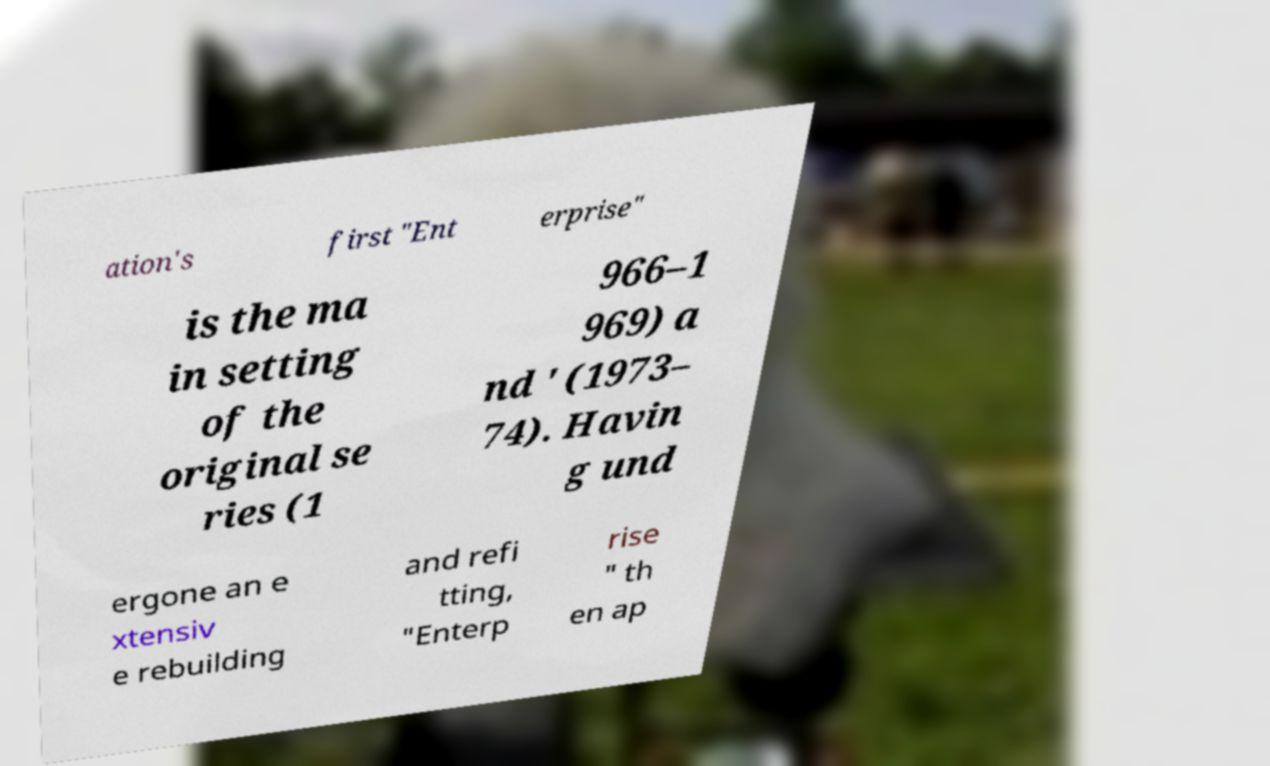Could you assist in decoding the text presented in this image and type it out clearly? ation's first "Ent erprise" is the ma in setting of the original se ries (1 966–1 969) a nd ' (1973– 74). Havin g und ergone an e xtensiv e rebuilding and refi tting, "Enterp rise " th en ap 